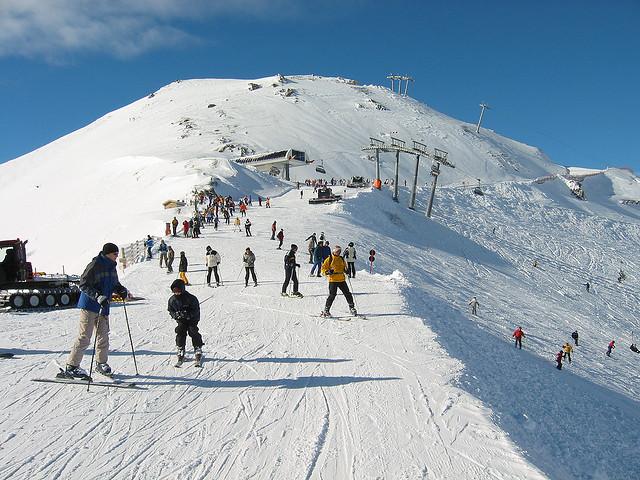Is there an event?
Be succinct. No. What are the people doing?
Answer briefly. Skiing. Is this a beach?
Keep it brief. No. 